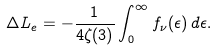Convert formula to latex. <formula><loc_0><loc_0><loc_500><loc_500>\Delta L _ { e } = - \frac { 1 } { 4 \zeta ( 3 ) } \int _ { 0 } ^ { \infty } f _ { \nu } ( \epsilon ) \, d \epsilon .</formula> 